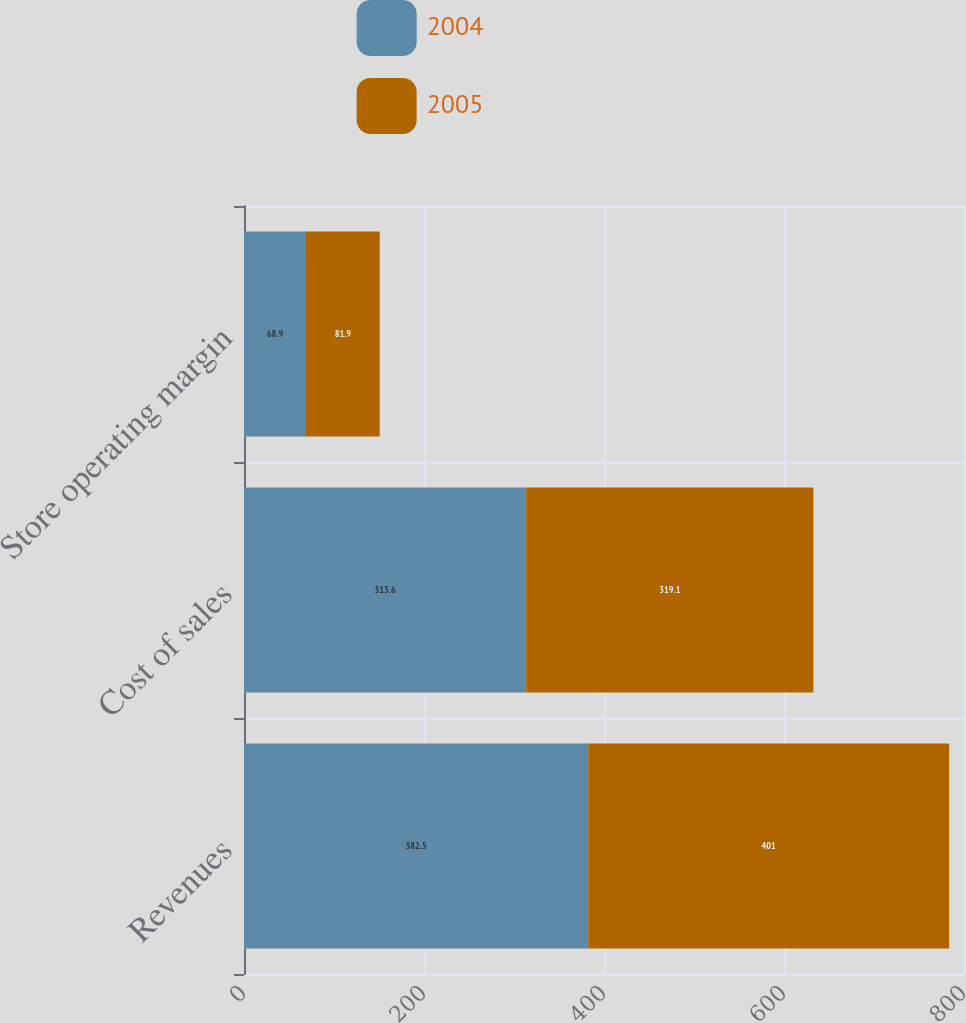<chart> <loc_0><loc_0><loc_500><loc_500><stacked_bar_chart><ecel><fcel>Revenues<fcel>Cost of sales<fcel>Store operating margin<nl><fcel>2004<fcel>382.5<fcel>313.6<fcel>68.9<nl><fcel>2005<fcel>401<fcel>319.1<fcel>81.9<nl></chart> 